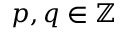<formula> <loc_0><loc_0><loc_500><loc_500>p , q \in \mathbb { Z }</formula> 